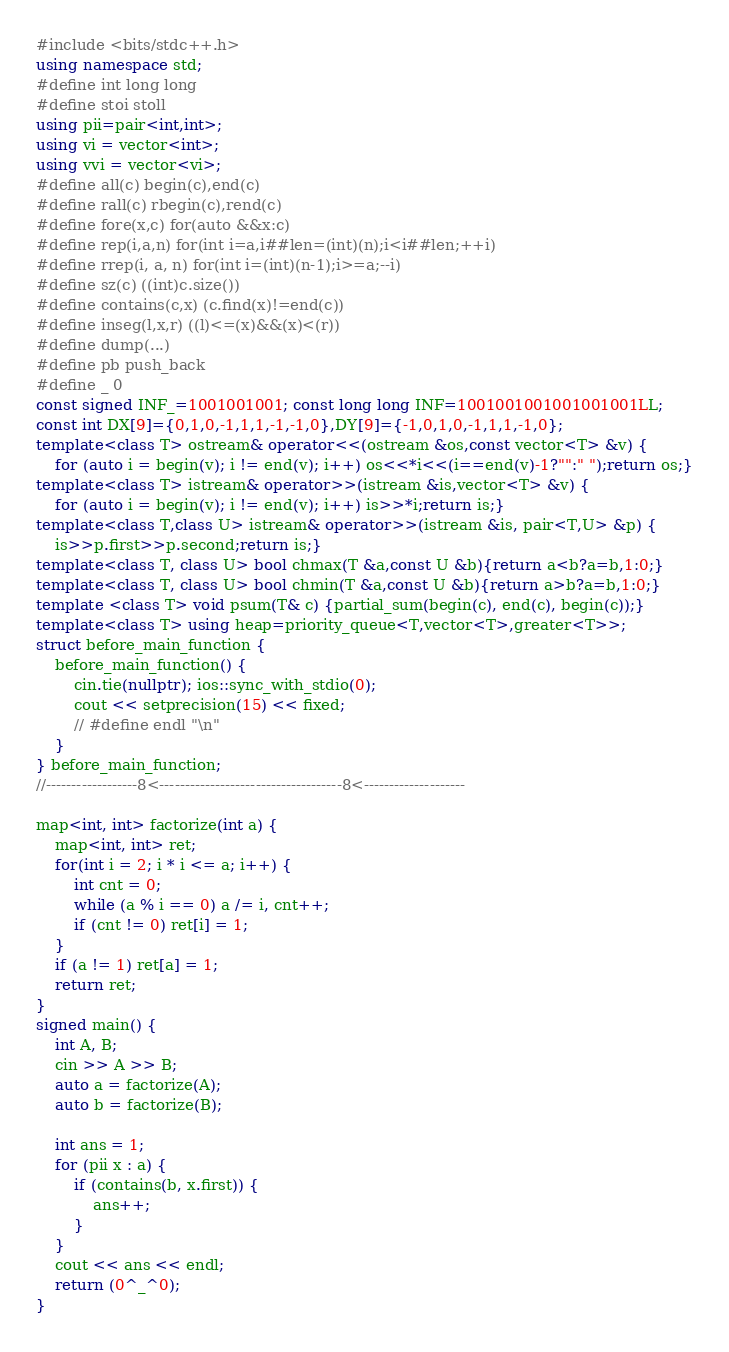Convert code to text. <code><loc_0><loc_0><loc_500><loc_500><_C++_>#include <bits/stdc++.h>
using namespace std;
#define int long long
#define stoi stoll
using pii=pair<int,int>;
using vi = vector<int>;
using vvi = vector<vi>;
#define all(c) begin(c),end(c)
#define rall(c) rbegin(c),rend(c)
#define fore(x,c) for(auto &&x:c)
#define rep(i,a,n) for(int i=a,i##len=(int)(n);i<i##len;++i)
#define rrep(i, a, n) for(int i=(int)(n-1);i>=a;--i)
#define sz(c) ((int)c.size())
#define contains(c,x) (c.find(x)!=end(c))
#define inseg(l,x,r) ((l)<=(x)&&(x)<(r))
#define dump(...)
#define pb push_back
#define _ 0
const signed INF_=1001001001; const long long INF=1001001001001001001LL;
const int DX[9]={0,1,0,-1,1,1,-1,-1,0},DY[9]={-1,0,1,0,-1,1,1,-1,0};
template<class T> ostream& operator<<(ostream &os,const vector<T> &v) {
    for (auto i = begin(v); i != end(v); i++) os<<*i<<(i==end(v)-1?"":" ");return os;}
template<class T> istream& operator>>(istream &is,vector<T> &v) {
    for (auto i = begin(v); i != end(v); i++) is>>*i;return is;}
template<class T,class U> istream& operator>>(istream &is, pair<T,U> &p) {
    is>>p.first>>p.second;return is;}
template<class T, class U> bool chmax(T &a,const U &b){return a<b?a=b,1:0;}
template<class T, class U> bool chmin(T &a,const U &b){return a>b?a=b,1:0;}
template <class T> void psum(T& c) {partial_sum(begin(c), end(c), begin(c));}
template<class T> using heap=priority_queue<T,vector<T>,greater<T>>;
struct before_main_function {
    before_main_function() {
        cin.tie(nullptr); ios::sync_with_stdio(0);
        cout << setprecision(15) << fixed;
        // #define endl "\n"
    }
} before_main_function;
//------------------8<------------------------------------8<--------------------

map<int, int> factorize(int a) {
    map<int, int> ret;
    for(int i = 2; i * i <= a; i++) {
        int cnt = 0;
        while (a % i == 0) a /= i, cnt++;
        if (cnt != 0) ret[i] = 1;
    }
    if (a != 1) ret[a] = 1;
    return ret;
}
signed main() {
    int A, B;
    cin >> A >> B;
    auto a = factorize(A);
    auto b = factorize(B);
    
    int ans = 1;
    for (pii x : a) {
        if (contains(b, x.first)) {
            ans++;
        }
    }
    cout << ans << endl;
    return (0^_^0);
}

</code> 